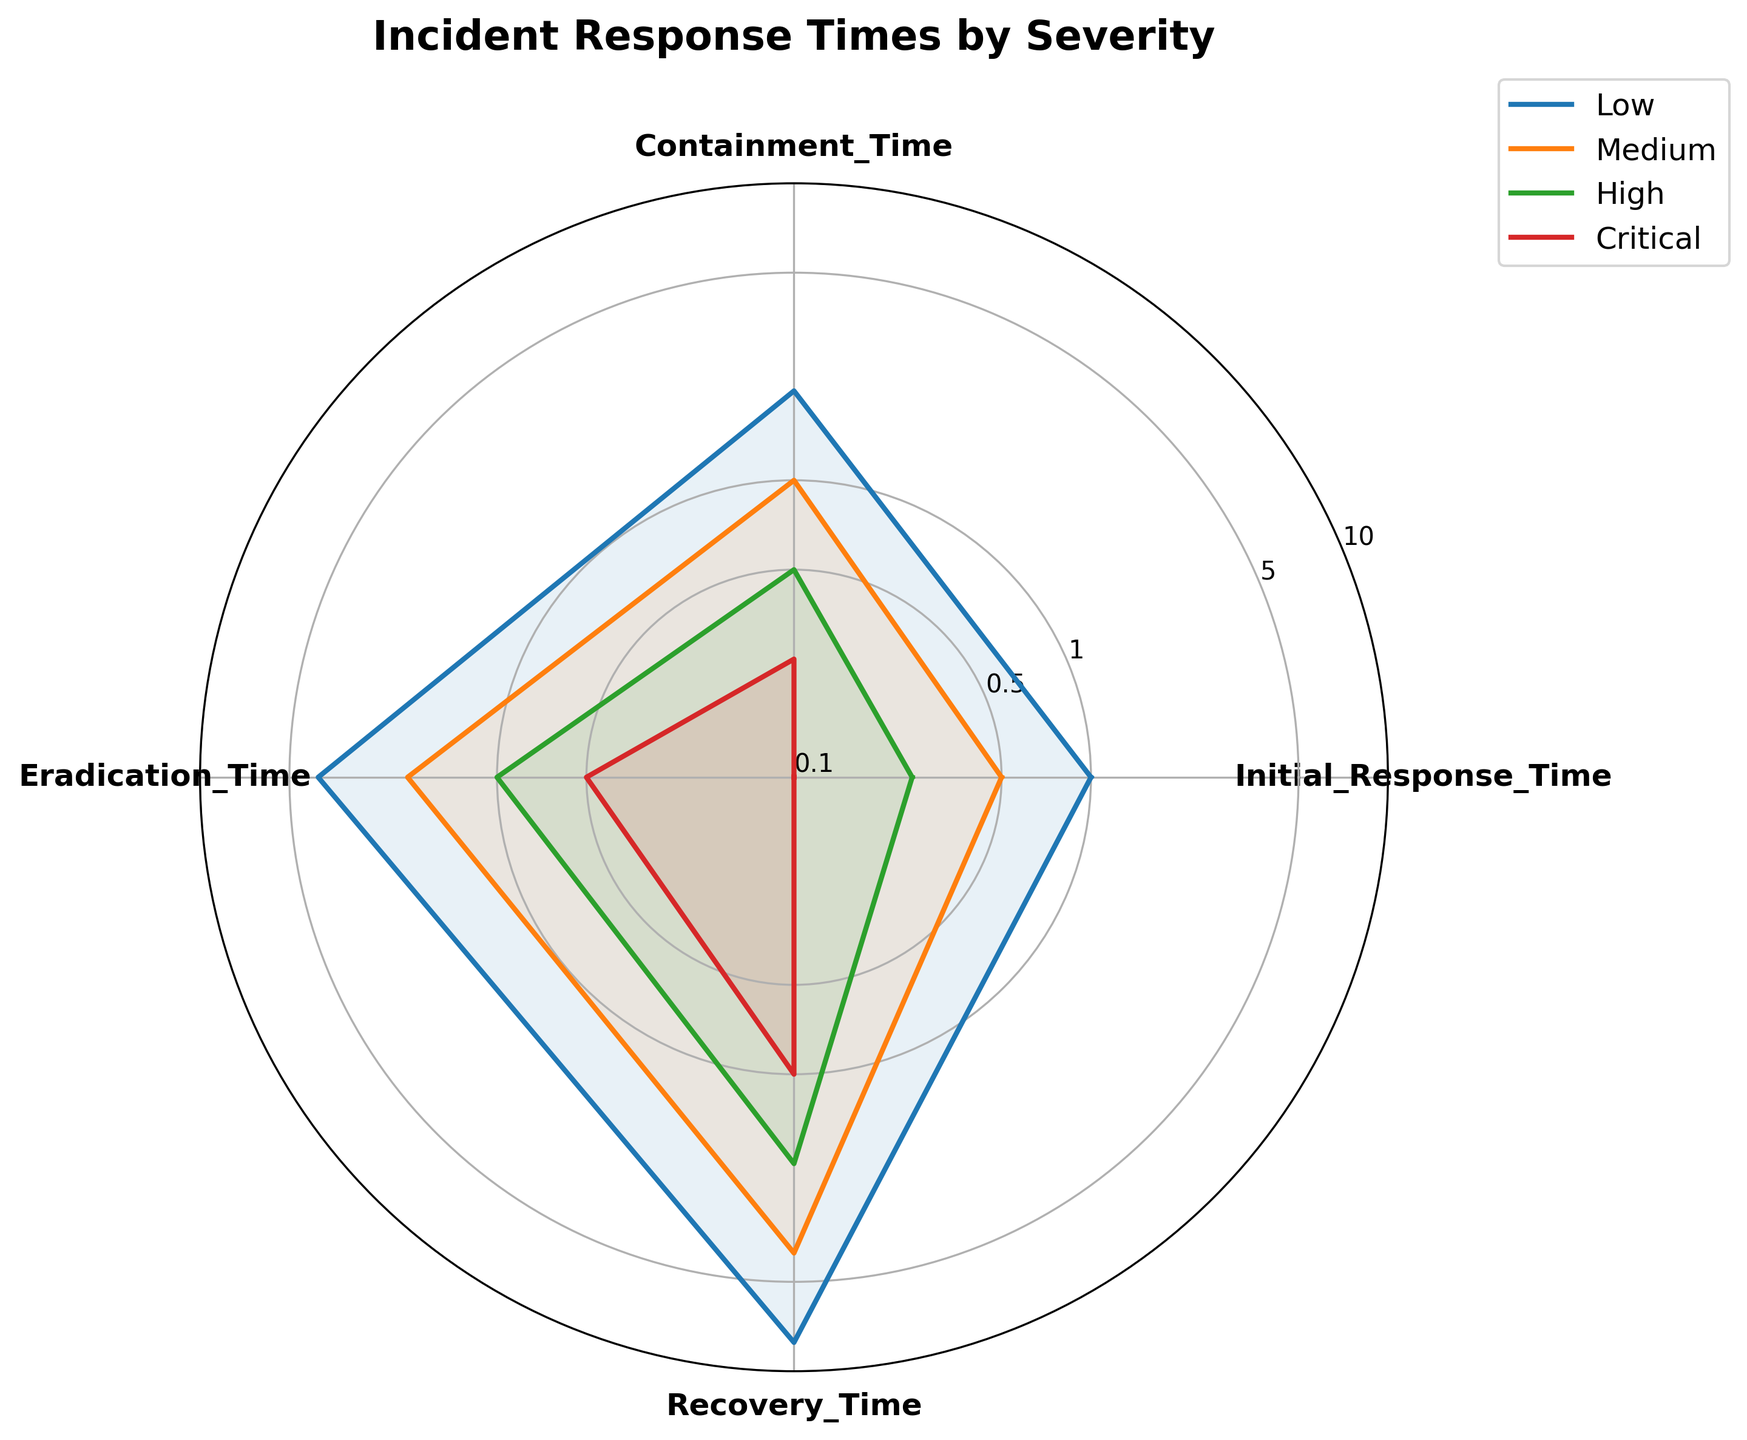How many categories of incident response times are shown in the radar chart? There are four category labels on the radar chart: Initial Response Time, Containment Time, Eradication Time, and Recovery Time.
Answer: 4 Which incident severity has the shortest initial response time? Looking at the plotted lines on the radar chart, the Critical severity line starts at the lowest point on the Initial Response Time axis.
Answer: Critical Which category of response time shows the most variation between different severities? The Recovery Time axis has the widest spread among plotted values for different severities compared to other axes.
Answer: Recovery Time What is the initial response time for medium severity incidents? The radar chart indicates that the point for Medium severity aligns with 0.5 hours on the Initial Response Time axis.
Answer: 0.5 hours For high severity incidents, is the recovery time greater or less than the containment time? Observing the High severity line on the chart shows that the value on the Recovery Time axis (2 hours) is greater than on the Containment Time axis (0.5 hours).
Answer: Greater Compare the initial response times between low and critical severity incidents. The Initial Response Time for Low severity (1 hour) is greater than for Critical severity (0.1 hours) as seen on the chart.
Answer: Low severity incident has greater initial response time What is the average containment time across all incident severities? Containment times are 2, 1, 0.5, and 0.25 hours. Sum: 2 + 1 + 0.5 + 0.25 = 3.75 hours. Average: 3.75 / 4 = 0.9375 hours.
Answer: 0.9375 hours Which incident severity requires the least time for eradication? The Critical severity line reaches the lowest point on the Eradication Time axis at 0.5 hours.
Answer: Critical How does the containment time for low severity compare to the recovery time for medium severity? The radar chart shows the Containment Time for Low severity as 2 hours and the Recovery Time for Medium severity as 4 hours.
Answer: Containment time for low severity is less For medium severity, what is the ratio of recovery time to initial response time? Recovery Time for Medium severity is 4 hours, and Initial Response Time is 0.5 hours. Ratio: 4 / 0.5 = 8.
Answer: 8 